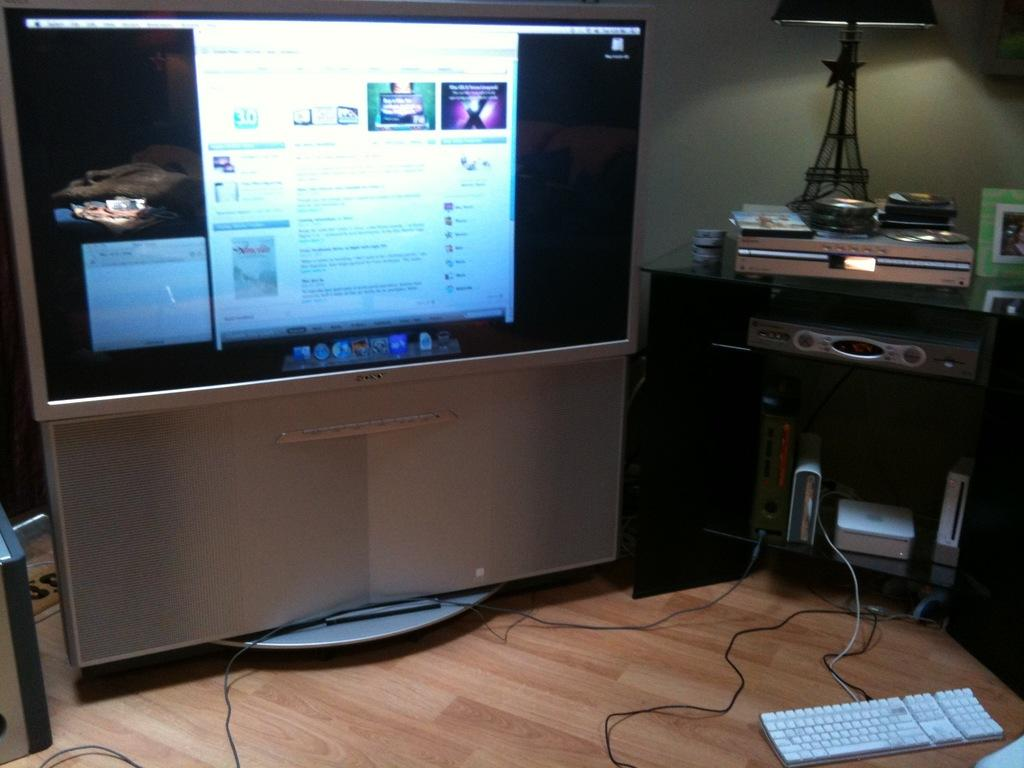What is located on the left side of the image? There is a monitor on the left side of the image. What can be seen on the right side of the image? There are electronic objects on the right side of the image. What piece of furniture is present in the image? There is a table in the image. What type of lighting is present in the image? There is a lamp in the image. Where is the keyboard located in the image? The keyboard is on the floor in the image. Can you see any stars in the image? There are no stars visible in the image. Is there a cave present in the image? There is no cave present in the image. 